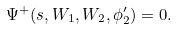Convert formula to latex. <formula><loc_0><loc_0><loc_500><loc_500>\Psi ^ { + } ( s , W _ { 1 } , W _ { 2 } , \phi ^ { \prime } _ { 2 } ) = 0 .</formula> 